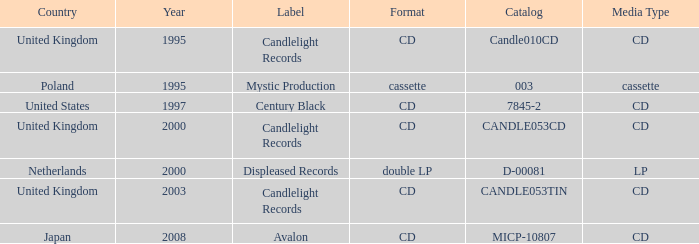What was the Candlelight Records Catalog of Candle053tin format? CD. 